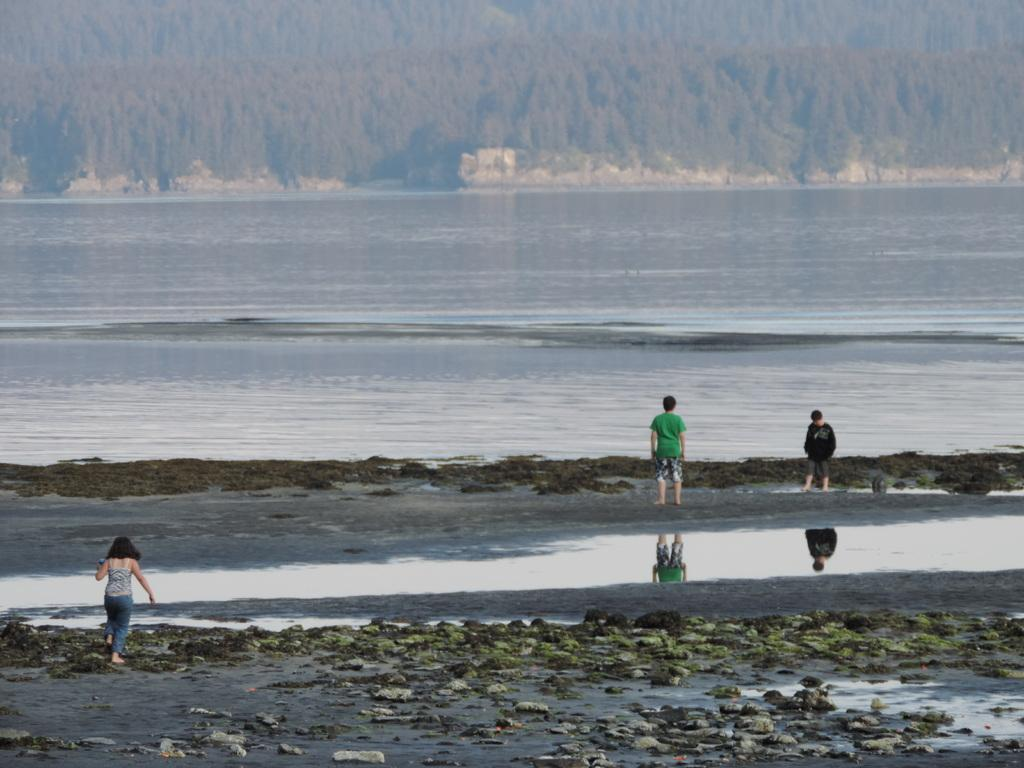What type of location is shown in the image? The image depicts a beach. How many people are present in the image? There are three people standing in the image. What can be seen in the background of the image? There is a sea visible in the background of the image. What type of vegetation is present at the top of the image? There are trees at the top of the image. How many eggs are being used to make the sandcastle in the image? There is no sandcastle or eggs present in the image. What type of shoes are the people wearing in the image? The provided facts do not mention the type of shoes the people are wearing in the image. 